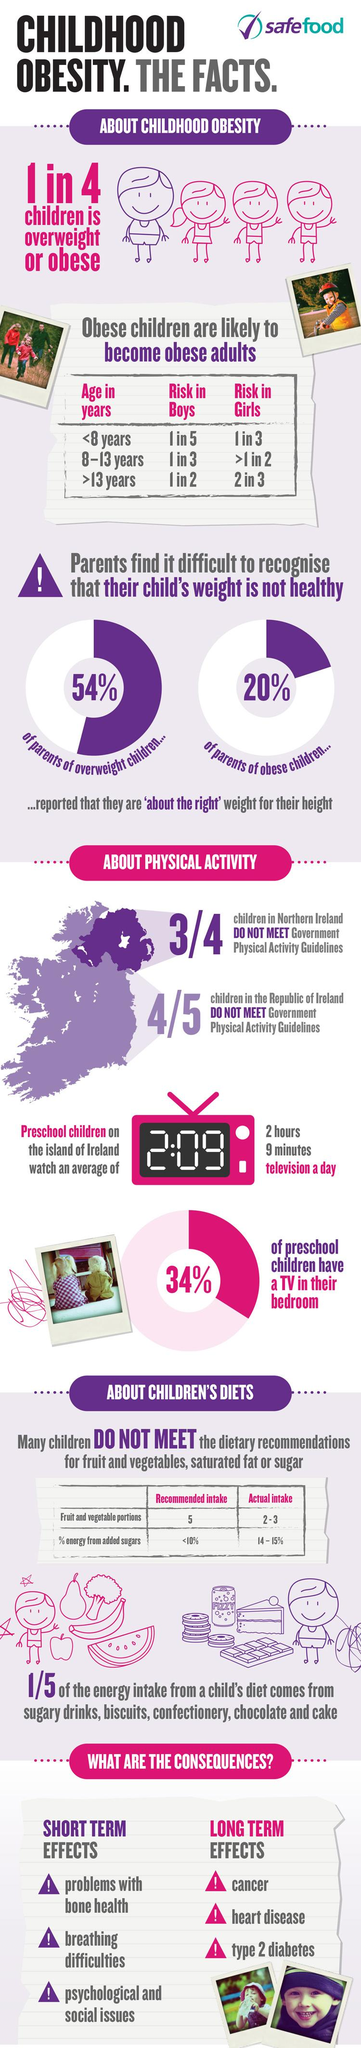Mention a couple of crucial points in this snapshot. The risk of obesity is high for boys aged 13 years or older. According to a recent survey, 46% of preschool children do not have a TV in their bedroom. 